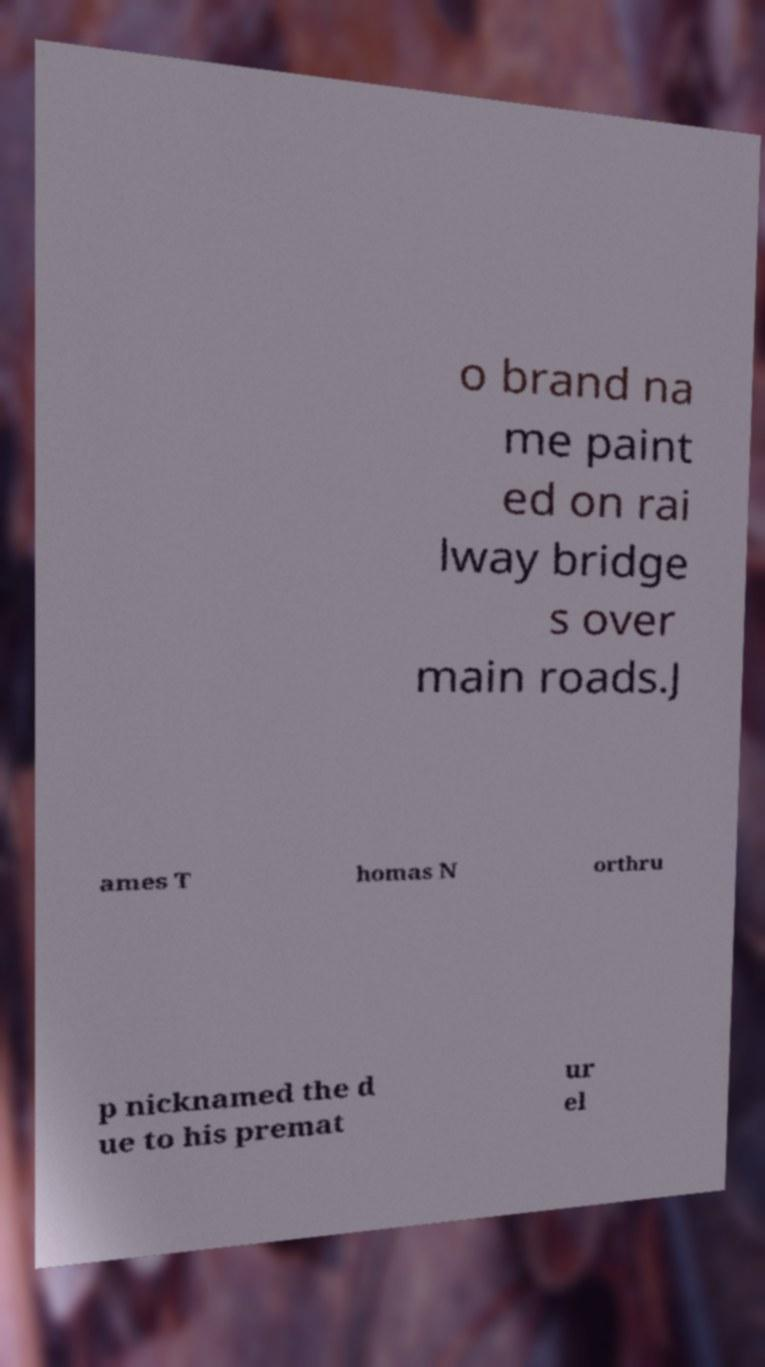Can you read and provide the text displayed in the image?This photo seems to have some interesting text. Can you extract and type it out for me? o brand na me paint ed on rai lway bridge s over main roads.J ames T homas N orthru p nicknamed the d ue to his premat ur el 